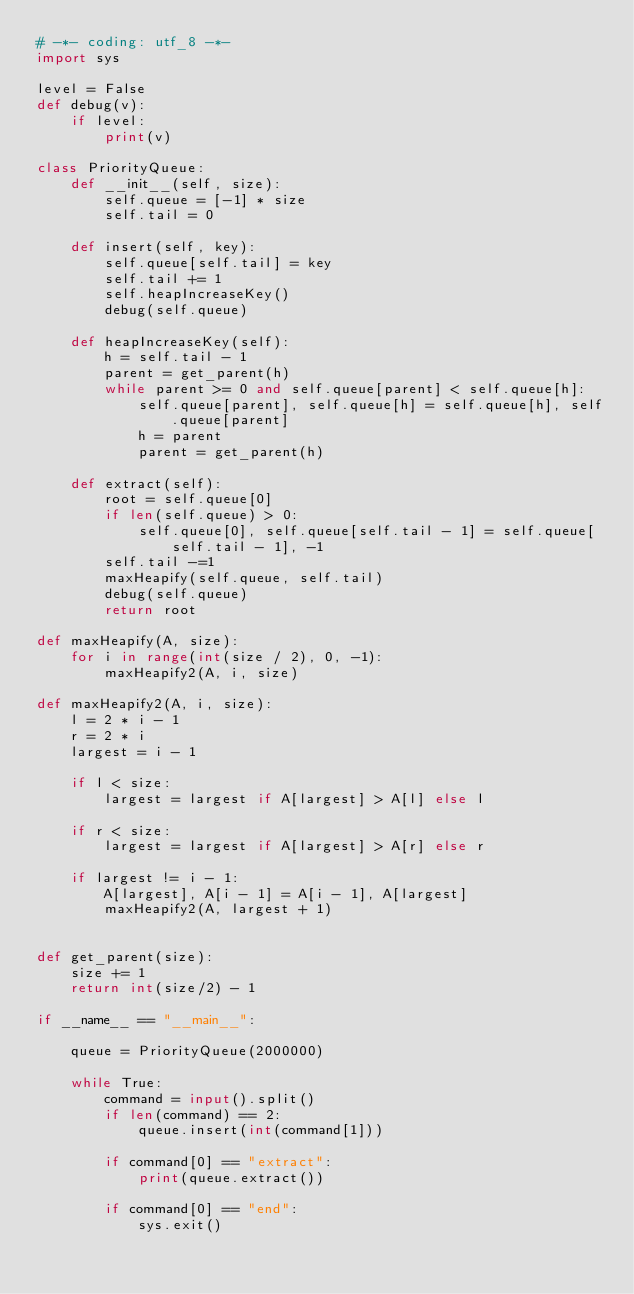Convert code to text. <code><loc_0><loc_0><loc_500><loc_500><_Python_># -*- coding: utf_8 -*-
import sys

level = False
def debug(v):
    if level:
        print(v)

class PriorityQueue:
    def __init__(self, size):
        self.queue = [-1] * size
        self.tail = 0

    def insert(self, key):
        self.queue[self.tail] = key
        self.tail += 1
        self.heapIncreaseKey()
        debug(self.queue)

    def heapIncreaseKey(self):
        h = self.tail - 1
        parent = get_parent(h)
        while parent >= 0 and self.queue[parent] < self.queue[h]:
            self.queue[parent], self.queue[h] = self.queue[h], self.queue[parent]
            h = parent
            parent = get_parent(h)

    def extract(self):
        root = self.queue[0]
        if len(self.queue) > 0:
            self.queue[0], self.queue[self.tail - 1] = self.queue[self.tail - 1], -1
        self.tail -=1
        maxHeapify(self.queue, self.tail)
        debug(self.queue)
        return root

def maxHeapify(A, size):
    for i in range(int(size / 2), 0, -1):
        maxHeapify2(A, i, size)

def maxHeapify2(A, i, size):
    l = 2 * i - 1
    r = 2 * i
    largest = i - 1

    if l < size:
        largest = largest if A[largest] > A[l] else l

    if r < size:
        largest = largest if A[largest] > A[r] else r

    if largest != i - 1:
        A[largest], A[i - 1] = A[i - 1], A[largest]
        maxHeapify2(A, largest + 1)


def get_parent(size):
    size += 1
    return int(size/2) - 1

if __name__ == "__main__":

    queue = PriorityQueue(2000000)

    while True:
        command = input().split()
        if len(command) == 2:
            queue.insert(int(command[1]))

        if command[0] == "extract":
            print(queue.extract())

        if command[0] == "end":
            sys.exit()</code> 